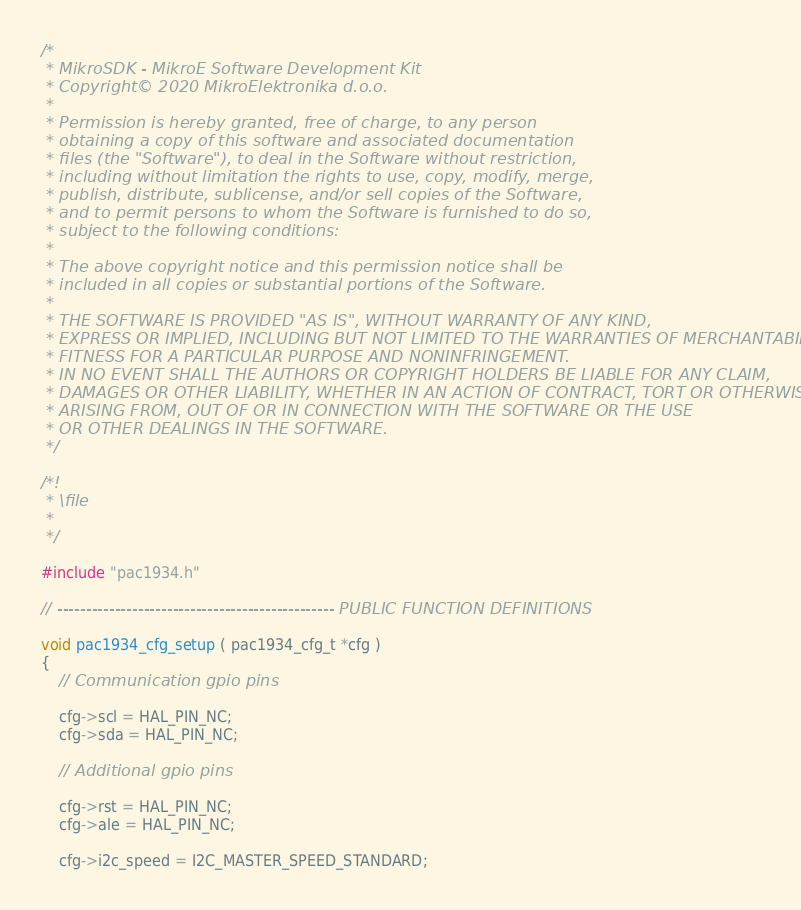<code> <loc_0><loc_0><loc_500><loc_500><_C_>/*
 * MikroSDK - MikroE Software Development Kit
 * Copyright© 2020 MikroElektronika d.o.o.
 * 
 * Permission is hereby granted, free of charge, to any person 
 * obtaining a copy of this software and associated documentation 
 * files (the "Software"), to deal in the Software without restriction, 
 * including without limitation the rights to use, copy, modify, merge, 
 * publish, distribute, sublicense, and/or sell copies of the Software, 
 * and to permit persons to whom the Software is furnished to do so, 
 * subject to the following conditions:
 * 
 * The above copyright notice and this permission notice shall be 
 * included in all copies or substantial portions of the Software.
 * 
 * THE SOFTWARE IS PROVIDED "AS IS", WITHOUT WARRANTY OF ANY KIND, 
 * EXPRESS OR IMPLIED, INCLUDING BUT NOT LIMITED TO THE WARRANTIES OF MERCHANTABILITY, 
 * FITNESS FOR A PARTICULAR PURPOSE AND NONINFRINGEMENT. 
 * IN NO EVENT SHALL THE AUTHORS OR COPYRIGHT HOLDERS BE LIABLE FOR ANY CLAIM,
 * DAMAGES OR OTHER LIABILITY, WHETHER IN AN ACTION OF CONTRACT, TORT OR OTHERWISE, 
 * ARISING FROM, OUT OF OR IN CONNECTION WITH THE SOFTWARE OR THE USE 
 * OR OTHER DEALINGS IN THE SOFTWARE. 
 */

/*!
 * \file
 *
 */

#include "pac1934.h"

// ------------------------------------------------ PUBLIC FUNCTION DEFINITIONS

void pac1934_cfg_setup ( pac1934_cfg_t *cfg )
{
    // Communication gpio pins 

    cfg->scl = HAL_PIN_NC;
    cfg->sda = HAL_PIN_NC;
    
    // Additional gpio pins

    cfg->rst = HAL_PIN_NC;
    cfg->ale = HAL_PIN_NC;

    cfg->i2c_speed = I2C_MASTER_SPEED_STANDARD; </code> 